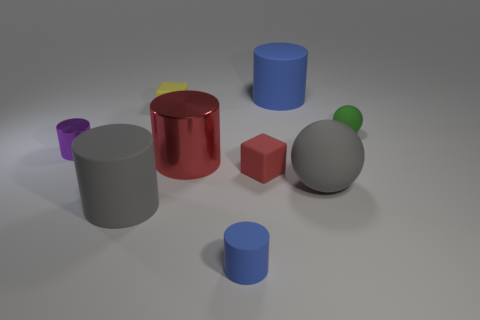Subtract all purple spheres. How many blue cylinders are left? 2 Subtract all tiny purple cylinders. How many cylinders are left? 4 Subtract all blue cylinders. How many cylinders are left? 3 Add 1 small green spheres. How many objects exist? 10 Subtract all cubes. How many objects are left? 7 Subtract all green cylinders. Subtract all yellow cubes. How many cylinders are left? 5 Subtract 0 brown cubes. How many objects are left? 9 Subtract all small purple things. Subtract all small purple cylinders. How many objects are left? 7 Add 1 green rubber spheres. How many green rubber spheres are left? 2 Add 2 tiny red things. How many tiny red things exist? 3 